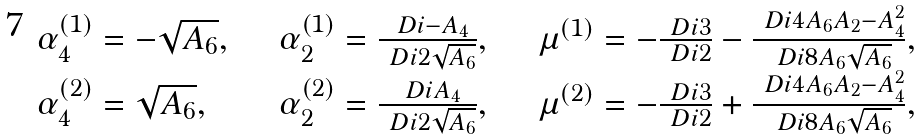Convert formula to latex. <formula><loc_0><loc_0><loc_500><loc_500>\begin{array} { l l l } \alpha _ { 4 } ^ { ( 1 ) } = - \sqrt { A _ { 6 } } , \quad & \alpha _ { 2 } ^ { ( 1 ) } = \frac { \ D i - A _ { 4 } } { \ D i 2 \sqrt { A _ { 6 } } } , \quad & \mu ^ { ( 1 ) } = - \frac { \ D i 3 } { \ D i 2 } - \frac { \ D i 4 A _ { 6 } A _ { 2 } - A _ { 4 } ^ { 2 } } { \ D i 8 A _ { 6 } \sqrt { A _ { 6 } } } , \\ \alpha _ { 4 } ^ { ( 2 ) } = \sqrt { A _ { 6 } } , \quad & \alpha _ { 2 } ^ { ( 2 ) } = \frac { \ D i A _ { 4 } } { \ D i 2 \sqrt { A _ { 6 } } } , \quad & \mu ^ { ( 2 ) } = - \frac { \ D i 3 } { \ D i 2 } + \frac { \ D i 4 A _ { 6 } A _ { 2 } - A _ { 4 } ^ { 2 } } { \ D i 8 A _ { 6 } \sqrt { A _ { 6 } } } , \end{array}</formula> 